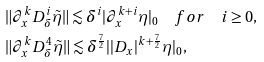<formula> <loc_0><loc_0><loc_500><loc_500>& \| \partial _ { x } ^ { k } D _ { \delta } ^ { i } \tilde { \eta } \| \lesssim \delta ^ { i } | \partial _ { x } ^ { k + i } \eta | _ { 0 } \quad f o r \quad i \geq 0 , \\ & \| \partial _ { x } ^ { k } D _ { \delta } ^ { 4 } \tilde { \eta } \| \lesssim \delta ^ { \frac { 7 } { 2 } } | | D _ { x } | ^ { k + \frac { 7 } { 2 } } \eta | _ { 0 } ,</formula> 